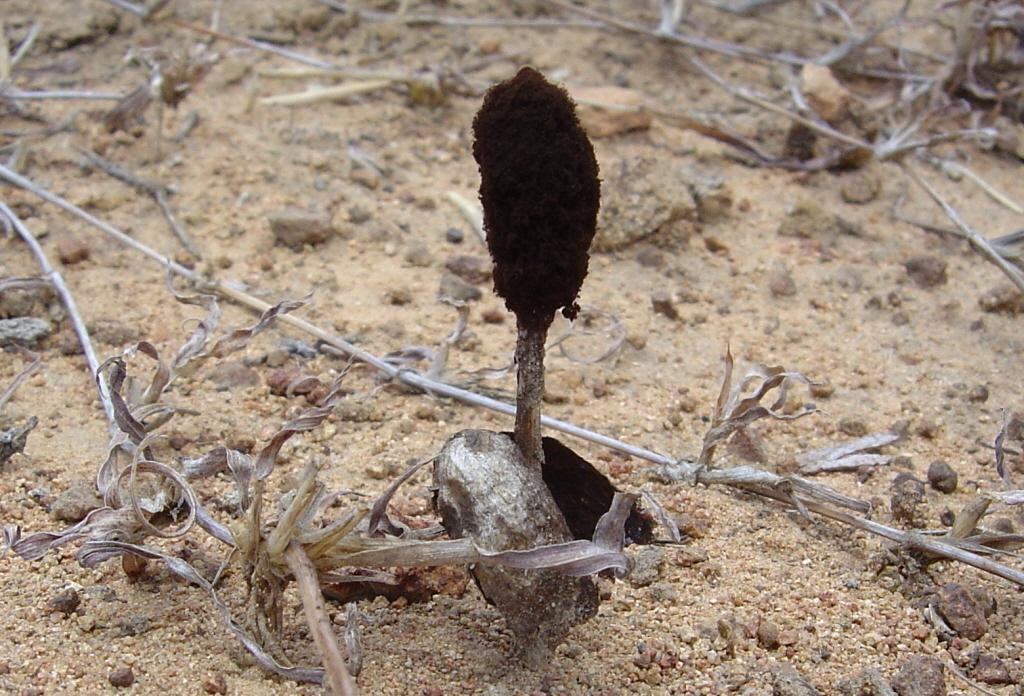What type of plants are in the image? There are dry plants in the image. What else can be seen in the image besides the plants? There are stones in the image. What is the name of the family member who operates the machine in the image? There is no family member or machine present in the image. 